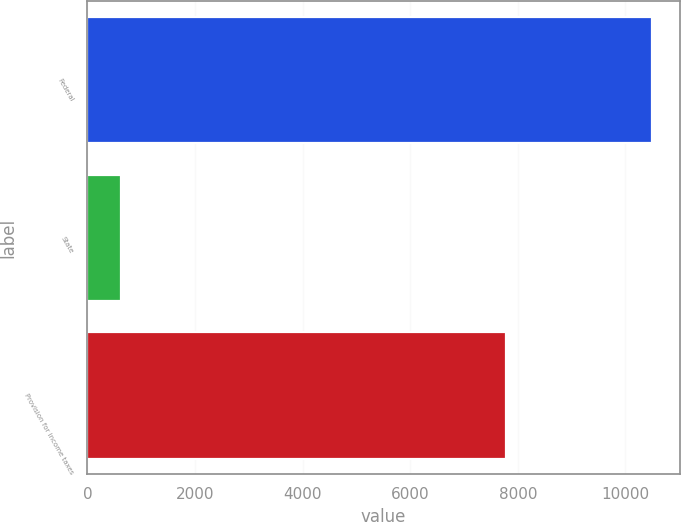<chart> <loc_0><loc_0><loc_500><loc_500><bar_chart><fcel>Federal<fcel>State<fcel>Provision for income taxes<nl><fcel>10485<fcel>630<fcel>7774<nl></chart> 